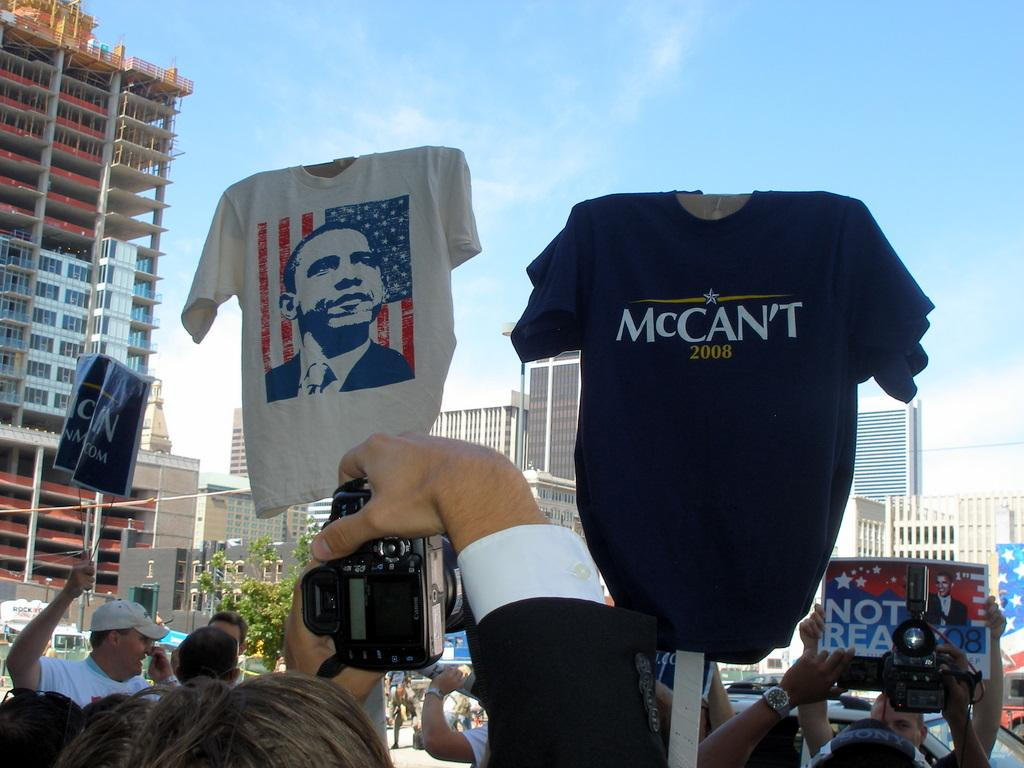<image>
Create a compact narrative representing the image presented. A blue Mccan't shirt with the year 2008 on it 